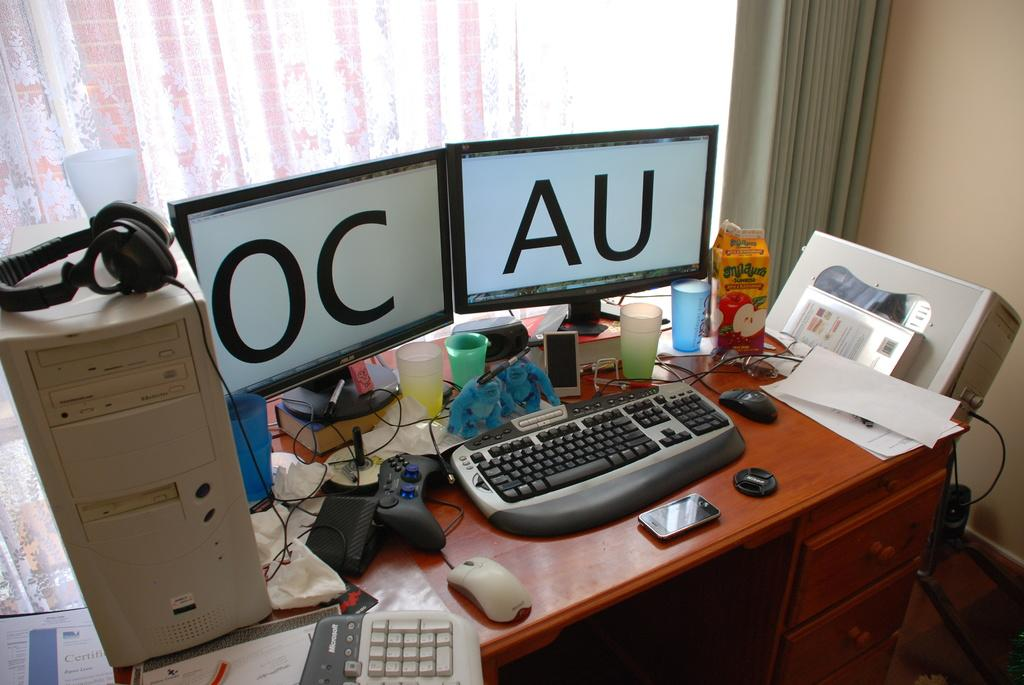What is the main subject of the image? There is a system in the image. What can be seen on the table in the image? There are papers and other objects on the table. What is the purpose of the glass in the image? The purpose of the glass is not clear from the image, but it could be for holding a drink or displaying something. What is visible through the window at the back of the image? The image does not show what is visible through the window. What type of button is being pressed by the grandfather in the image? There is no grandfather or button present in the image. What type of vegetable is being used as a paperweight in the image? There are no vegetables present in the image, and the papers are not being held down by any objects. 